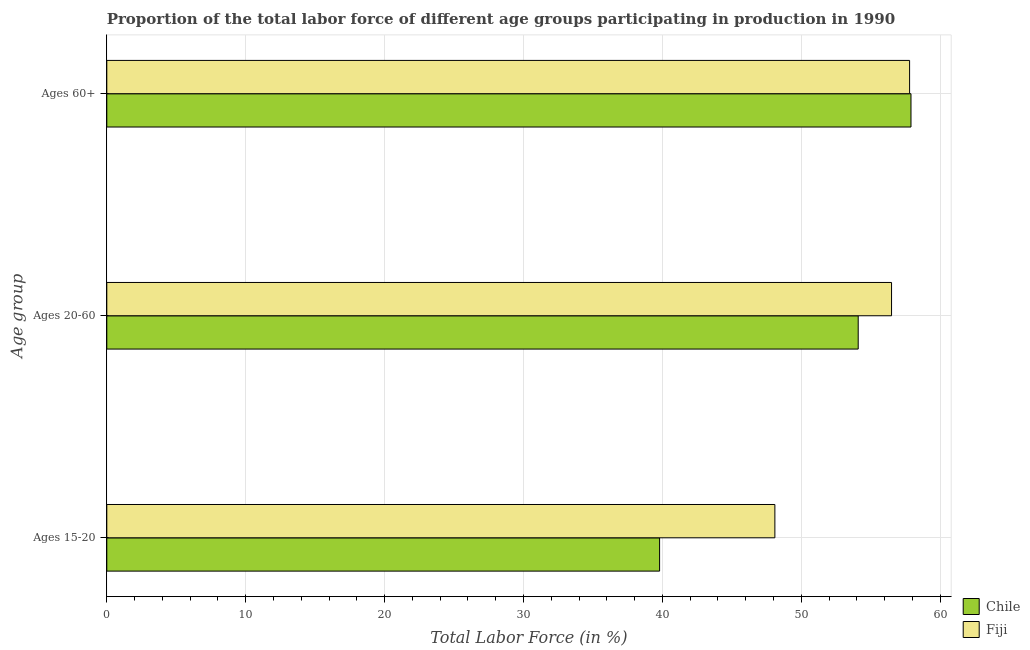How many different coloured bars are there?
Make the answer very short. 2. How many groups of bars are there?
Provide a short and direct response. 3. Are the number of bars on each tick of the Y-axis equal?
Provide a succinct answer. Yes. How many bars are there on the 3rd tick from the top?
Your answer should be compact. 2. How many bars are there on the 2nd tick from the bottom?
Your response must be concise. 2. What is the label of the 1st group of bars from the top?
Make the answer very short. Ages 60+. What is the percentage of labor force within the age group 15-20 in Fiji?
Make the answer very short. 48.1. Across all countries, what is the maximum percentage of labor force within the age group 15-20?
Provide a short and direct response. 48.1. Across all countries, what is the minimum percentage of labor force within the age group 15-20?
Make the answer very short. 39.8. In which country was the percentage of labor force within the age group 15-20 maximum?
Keep it short and to the point. Fiji. In which country was the percentage of labor force above age 60 minimum?
Provide a short and direct response. Fiji. What is the total percentage of labor force above age 60 in the graph?
Make the answer very short. 115.7. What is the difference between the percentage of labor force above age 60 in Fiji and that in Chile?
Your answer should be very brief. -0.1. What is the difference between the percentage of labor force within the age group 15-20 in Chile and the percentage of labor force within the age group 20-60 in Fiji?
Offer a terse response. -16.7. What is the average percentage of labor force within the age group 20-60 per country?
Your answer should be very brief. 55.3. What is the difference between the percentage of labor force within the age group 15-20 and percentage of labor force above age 60 in Chile?
Ensure brevity in your answer.  -18.1. In how many countries, is the percentage of labor force within the age group 20-60 greater than 6 %?
Ensure brevity in your answer.  2. What is the ratio of the percentage of labor force within the age group 15-20 in Chile to that in Fiji?
Give a very brief answer. 0.83. Is the difference between the percentage of labor force within the age group 15-20 in Fiji and Chile greater than the difference between the percentage of labor force within the age group 20-60 in Fiji and Chile?
Your response must be concise. Yes. What is the difference between the highest and the second highest percentage of labor force within the age group 15-20?
Your response must be concise. 8.3. What is the difference between the highest and the lowest percentage of labor force above age 60?
Your answer should be compact. 0.1. What does the 1st bar from the top in Ages 20-60 represents?
Your answer should be very brief. Fiji. What does the 2nd bar from the bottom in Ages 20-60 represents?
Keep it short and to the point. Fiji. Is it the case that in every country, the sum of the percentage of labor force within the age group 15-20 and percentage of labor force within the age group 20-60 is greater than the percentage of labor force above age 60?
Ensure brevity in your answer.  Yes. How many bars are there?
Your response must be concise. 6. Are all the bars in the graph horizontal?
Your response must be concise. Yes. What is the difference between two consecutive major ticks on the X-axis?
Keep it short and to the point. 10. Are the values on the major ticks of X-axis written in scientific E-notation?
Ensure brevity in your answer.  No. Does the graph contain any zero values?
Your answer should be compact. No. Does the graph contain grids?
Provide a succinct answer. Yes. How many legend labels are there?
Your answer should be very brief. 2. What is the title of the graph?
Offer a terse response. Proportion of the total labor force of different age groups participating in production in 1990. What is the label or title of the Y-axis?
Offer a very short reply. Age group. What is the Total Labor Force (in %) of Chile in Ages 15-20?
Ensure brevity in your answer.  39.8. What is the Total Labor Force (in %) of Fiji in Ages 15-20?
Offer a terse response. 48.1. What is the Total Labor Force (in %) of Chile in Ages 20-60?
Make the answer very short. 54.1. What is the Total Labor Force (in %) in Fiji in Ages 20-60?
Keep it short and to the point. 56.5. What is the Total Labor Force (in %) of Chile in Ages 60+?
Your answer should be compact. 57.9. What is the Total Labor Force (in %) of Fiji in Ages 60+?
Provide a short and direct response. 57.8. Across all Age group, what is the maximum Total Labor Force (in %) of Chile?
Your response must be concise. 57.9. Across all Age group, what is the maximum Total Labor Force (in %) of Fiji?
Provide a short and direct response. 57.8. Across all Age group, what is the minimum Total Labor Force (in %) in Chile?
Your answer should be compact. 39.8. Across all Age group, what is the minimum Total Labor Force (in %) in Fiji?
Ensure brevity in your answer.  48.1. What is the total Total Labor Force (in %) in Chile in the graph?
Your answer should be compact. 151.8. What is the total Total Labor Force (in %) of Fiji in the graph?
Keep it short and to the point. 162.4. What is the difference between the Total Labor Force (in %) of Chile in Ages 15-20 and that in Ages 20-60?
Provide a succinct answer. -14.3. What is the difference between the Total Labor Force (in %) in Chile in Ages 15-20 and that in Ages 60+?
Your response must be concise. -18.1. What is the difference between the Total Labor Force (in %) in Chile in Ages 15-20 and the Total Labor Force (in %) in Fiji in Ages 20-60?
Provide a short and direct response. -16.7. What is the difference between the Total Labor Force (in %) of Chile in Ages 20-60 and the Total Labor Force (in %) of Fiji in Ages 60+?
Make the answer very short. -3.7. What is the average Total Labor Force (in %) of Chile per Age group?
Make the answer very short. 50.6. What is the average Total Labor Force (in %) in Fiji per Age group?
Ensure brevity in your answer.  54.13. What is the difference between the Total Labor Force (in %) in Chile and Total Labor Force (in %) in Fiji in Ages 15-20?
Keep it short and to the point. -8.3. What is the difference between the Total Labor Force (in %) of Chile and Total Labor Force (in %) of Fiji in Ages 20-60?
Your response must be concise. -2.4. What is the ratio of the Total Labor Force (in %) of Chile in Ages 15-20 to that in Ages 20-60?
Offer a terse response. 0.74. What is the ratio of the Total Labor Force (in %) in Fiji in Ages 15-20 to that in Ages 20-60?
Your response must be concise. 0.85. What is the ratio of the Total Labor Force (in %) of Chile in Ages 15-20 to that in Ages 60+?
Your answer should be compact. 0.69. What is the ratio of the Total Labor Force (in %) of Fiji in Ages 15-20 to that in Ages 60+?
Your answer should be compact. 0.83. What is the ratio of the Total Labor Force (in %) in Chile in Ages 20-60 to that in Ages 60+?
Offer a terse response. 0.93. What is the ratio of the Total Labor Force (in %) in Fiji in Ages 20-60 to that in Ages 60+?
Your response must be concise. 0.98. What is the difference between the highest and the second highest Total Labor Force (in %) in Chile?
Your response must be concise. 3.8. 